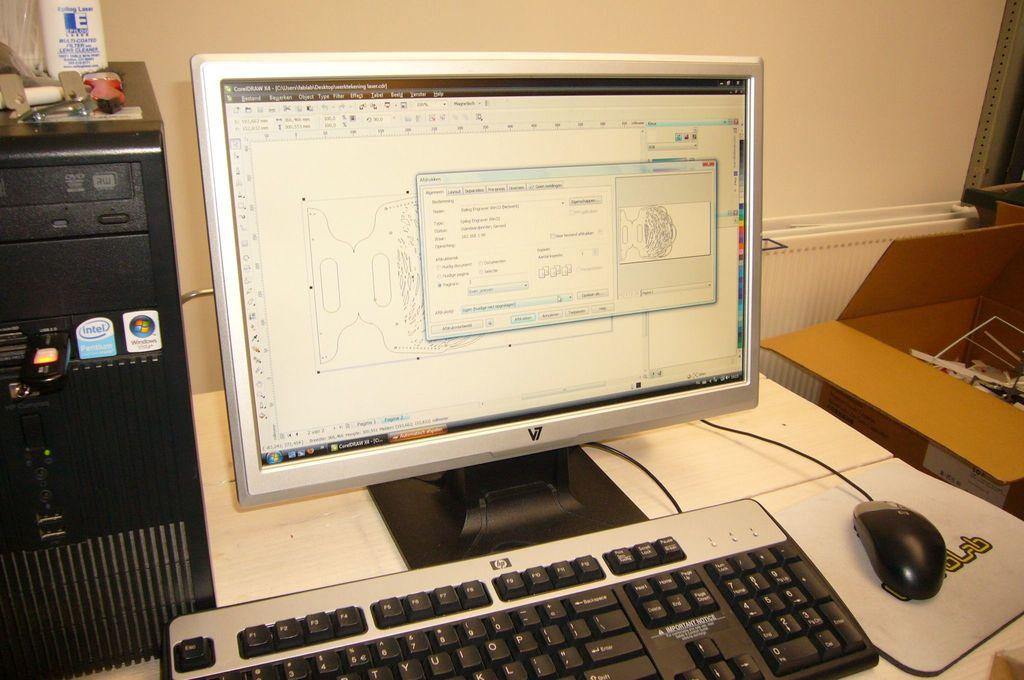What is the brand of the keyboard?
Provide a short and direct response. Hp. 